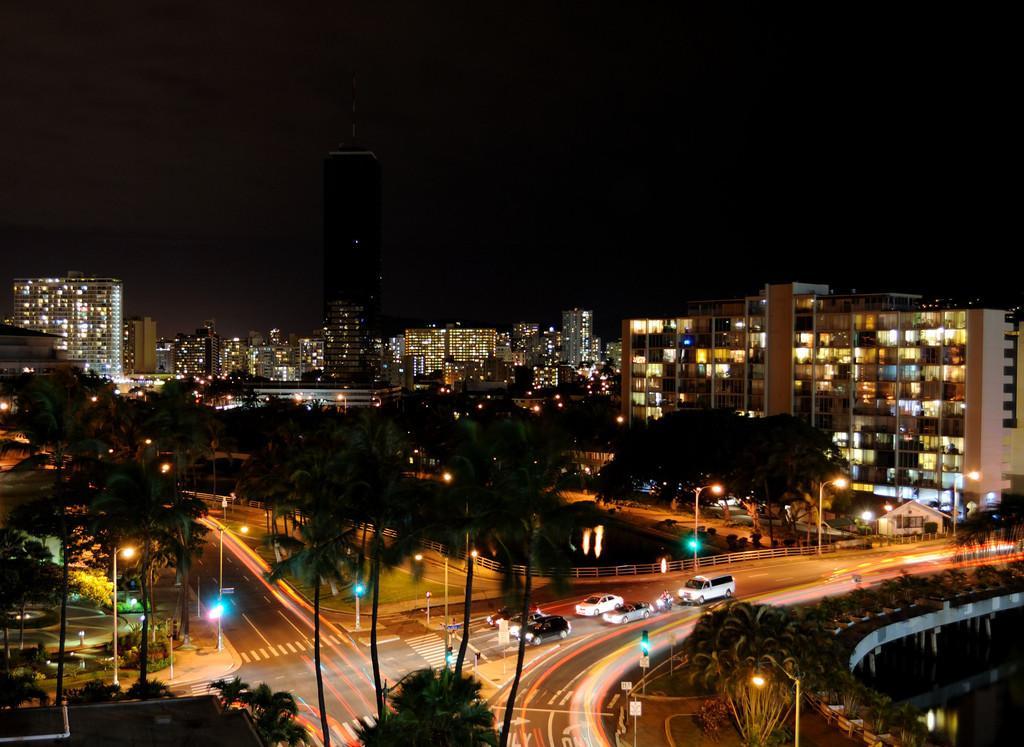Could you give a brief overview of what you see in this image? In this image I can see buildings. There are trees, roads, vehicles, lights, boards and in the background there is sky. 